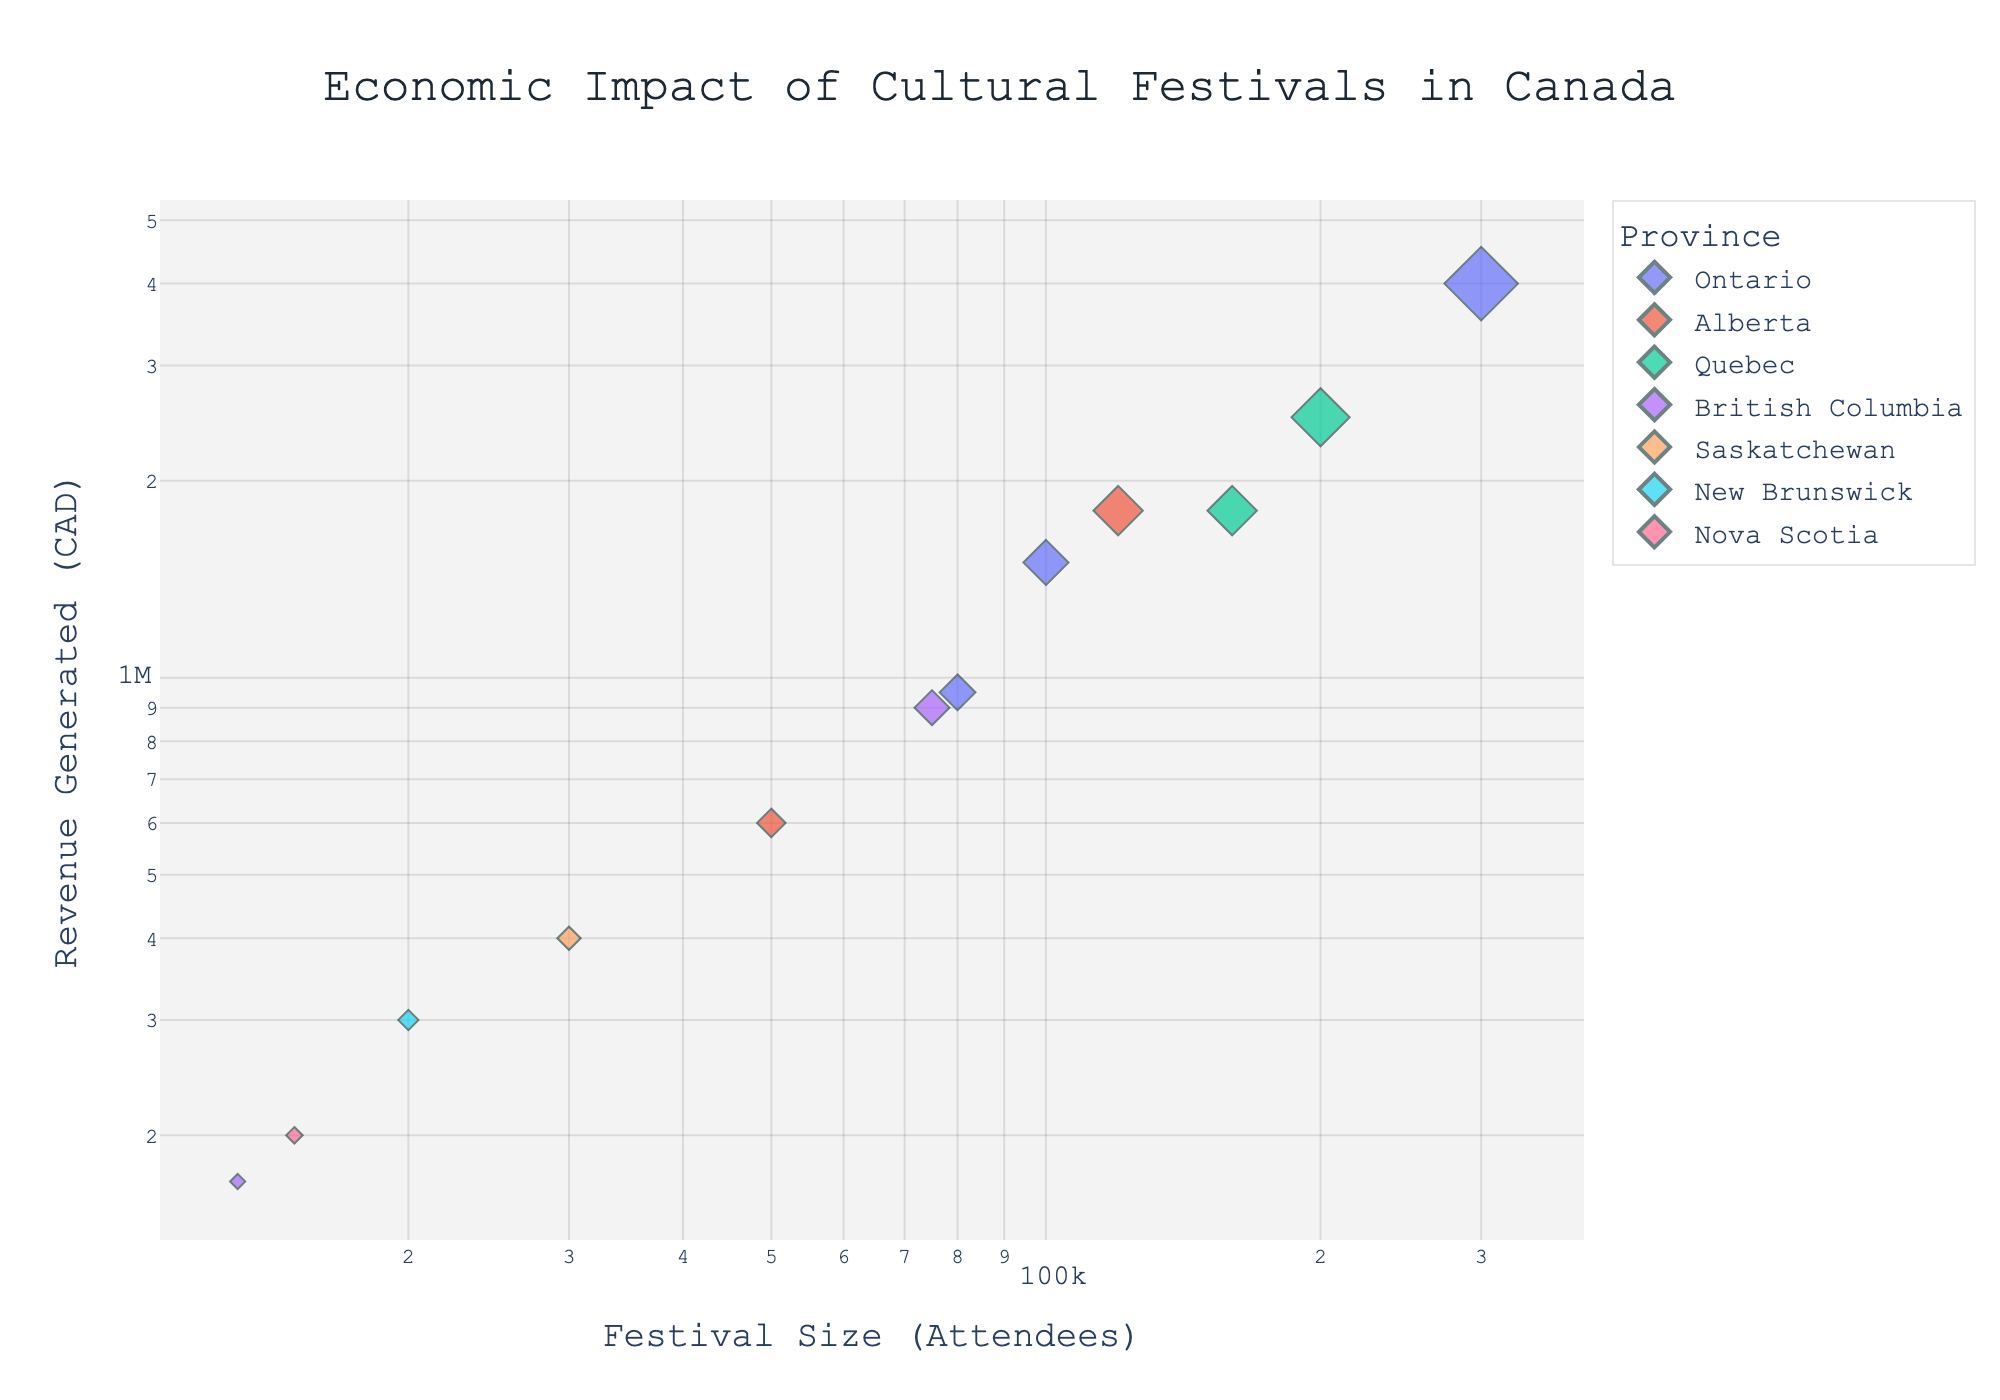How many Canadian provinces are represented in the scatter plot? Identify the different colors in the legend that correspond to the provinces. Count the unique provinces listed.
Answer: 6 What is the title of the scatter plot? Look at the top of the scatter plot where the title is typically placed.
Answer: Economic Impact of Cultural Festivals in Canada Which festival has the highest revenue generated? Look for the point representing the highest value on the y-axis (Revenue Generated). Check the hover name for that point.
Answer: Toronto International Film Festival What is the size of the smallest festival presented in the plot? Identify the point on the x-axis with the smallest value for Festival Size. Check the hover name to confirm the festival.
Answer: Sunshine Coast Festival of the Written Arts How does the festival size correlate with the revenue generated? Observe the general trend in the scatter plot by noting the spread and direction of data points. More attendees generally mean more revenue.
Answer: Positive correlation Which province has the festival with the largest attendance size? Identify the point with the highest x-value (Festival Size). Note the color and hover name corresponding to the festival and province.
Answer: Ontario Compare the revenue generated by the Caribbean Carnival and the Calgary Stampede. Which one is higher? Locate the points for Caribbean Carnival and Calgary Stampede. Compare their y-values (Revenue Generated).
Answer: Calgary Stampede What is the total revenue generated by all festivals in Alberta? Identify the points for festivals in Alberta (based on color). Sum their y-values (Revenue Generated).
Answer: 2,400,000 CAD Which festival has the closest size to 100,000 attendees and what is its revenue? Find the point nearest to 100,000 on the x-axis. Check the hover name and note the corresponding y-value (Revenue Generated).
Answer: Caribbean Carnival, 1,500,000 CAD Identify two festivals with similar revenue but from different provinces. Look for two points with similar y-values (Revenue Generated) but different colors in the scatter plot.
Answer: Calgary Stampede (Alberta) and FrancoFolies de Montreal (Quebec) 